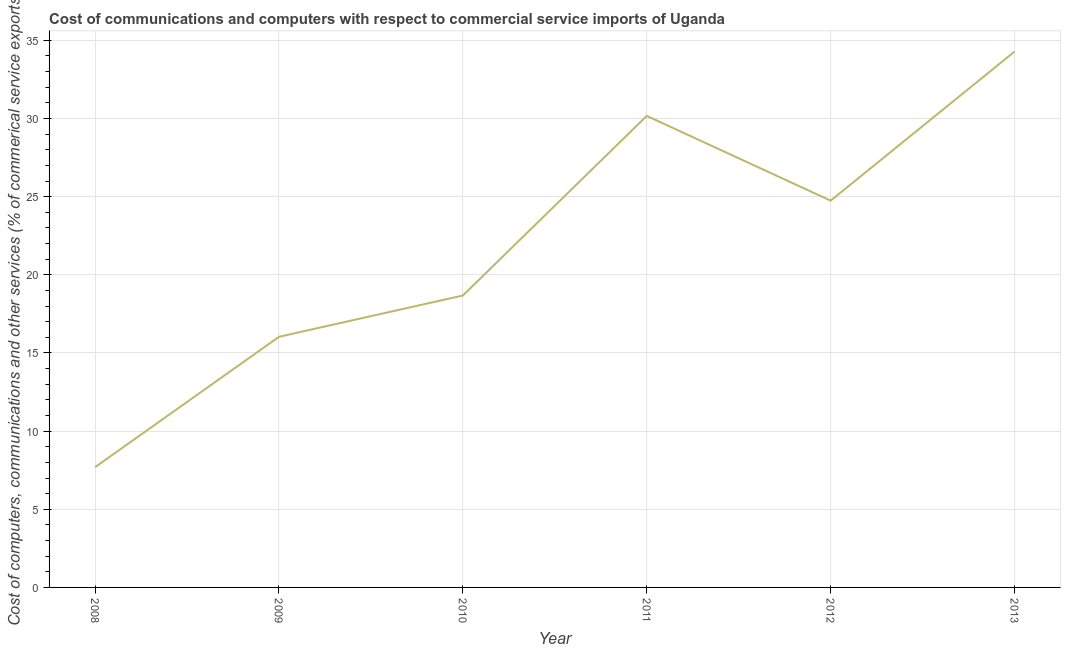What is the  computer and other services in 2010?
Keep it short and to the point. 18.68. Across all years, what is the maximum  computer and other services?
Your answer should be very brief. 34.28. Across all years, what is the minimum  computer and other services?
Offer a very short reply. 7.7. In which year was the  computer and other services maximum?
Your answer should be compact. 2013. What is the sum of the  computer and other services?
Offer a terse response. 131.6. What is the difference between the cost of communications in 2012 and 2013?
Give a very brief answer. -9.53. What is the average  computer and other services per year?
Give a very brief answer. 21.93. What is the median  computer and other services?
Your answer should be compact. 21.71. What is the ratio of the cost of communications in 2008 to that in 2009?
Keep it short and to the point. 0.48. What is the difference between the highest and the second highest  computer and other services?
Provide a short and direct response. 4.11. What is the difference between the highest and the lowest cost of communications?
Offer a terse response. 26.58. How many years are there in the graph?
Offer a very short reply. 6. What is the difference between two consecutive major ticks on the Y-axis?
Provide a short and direct response. 5. Does the graph contain grids?
Give a very brief answer. Yes. What is the title of the graph?
Your response must be concise. Cost of communications and computers with respect to commercial service imports of Uganda. What is the label or title of the Y-axis?
Provide a short and direct response. Cost of computers, communications and other services (% of commerical service exports). What is the Cost of computers, communications and other services (% of commerical service exports) of 2008?
Offer a terse response. 7.7. What is the Cost of computers, communications and other services (% of commerical service exports) in 2009?
Provide a succinct answer. 16.03. What is the Cost of computers, communications and other services (% of commerical service exports) in 2010?
Provide a succinct answer. 18.68. What is the Cost of computers, communications and other services (% of commerical service exports) of 2011?
Provide a short and direct response. 30.17. What is the Cost of computers, communications and other services (% of commerical service exports) of 2012?
Your answer should be very brief. 24.74. What is the Cost of computers, communications and other services (% of commerical service exports) of 2013?
Ensure brevity in your answer.  34.28. What is the difference between the Cost of computers, communications and other services (% of commerical service exports) in 2008 and 2009?
Make the answer very short. -8.34. What is the difference between the Cost of computers, communications and other services (% of commerical service exports) in 2008 and 2010?
Your response must be concise. -10.98. What is the difference between the Cost of computers, communications and other services (% of commerical service exports) in 2008 and 2011?
Your answer should be very brief. -22.47. What is the difference between the Cost of computers, communications and other services (% of commerical service exports) in 2008 and 2012?
Ensure brevity in your answer.  -17.05. What is the difference between the Cost of computers, communications and other services (% of commerical service exports) in 2008 and 2013?
Your answer should be compact. -26.58. What is the difference between the Cost of computers, communications and other services (% of commerical service exports) in 2009 and 2010?
Ensure brevity in your answer.  -2.64. What is the difference between the Cost of computers, communications and other services (% of commerical service exports) in 2009 and 2011?
Make the answer very short. -14.13. What is the difference between the Cost of computers, communications and other services (% of commerical service exports) in 2009 and 2012?
Your answer should be compact. -8.71. What is the difference between the Cost of computers, communications and other services (% of commerical service exports) in 2009 and 2013?
Provide a short and direct response. -18.25. What is the difference between the Cost of computers, communications and other services (% of commerical service exports) in 2010 and 2011?
Your answer should be very brief. -11.49. What is the difference between the Cost of computers, communications and other services (% of commerical service exports) in 2010 and 2012?
Ensure brevity in your answer.  -6.07. What is the difference between the Cost of computers, communications and other services (% of commerical service exports) in 2010 and 2013?
Keep it short and to the point. -15.6. What is the difference between the Cost of computers, communications and other services (% of commerical service exports) in 2011 and 2012?
Offer a very short reply. 5.42. What is the difference between the Cost of computers, communications and other services (% of commerical service exports) in 2011 and 2013?
Your response must be concise. -4.11. What is the difference between the Cost of computers, communications and other services (% of commerical service exports) in 2012 and 2013?
Offer a terse response. -9.53. What is the ratio of the Cost of computers, communications and other services (% of commerical service exports) in 2008 to that in 2009?
Provide a short and direct response. 0.48. What is the ratio of the Cost of computers, communications and other services (% of commerical service exports) in 2008 to that in 2010?
Your answer should be very brief. 0.41. What is the ratio of the Cost of computers, communications and other services (% of commerical service exports) in 2008 to that in 2011?
Provide a short and direct response. 0.26. What is the ratio of the Cost of computers, communications and other services (% of commerical service exports) in 2008 to that in 2012?
Your response must be concise. 0.31. What is the ratio of the Cost of computers, communications and other services (% of commerical service exports) in 2008 to that in 2013?
Provide a short and direct response. 0.23. What is the ratio of the Cost of computers, communications and other services (% of commerical service exports) in 2009 to that in 2010?
Provide a short and direct response. 0.86. What is the ratio of the Cost of computers, communications and other services (% of commerical service exports) in 2009 to that in 2011?
Keep it short and to the point. 0.53. What is the ratio of the Cost of computers, communications and other services (% of commerical service exports) in 2009 to that in 2012?
Offer a terse response. 0.65. What is the ratio of the Cost of computers, communications and other services (% of commerical service exports) in 2009 to that in 2013?
Give a very brief answer. 0.47. What is the ratio of the Cost of computers, communications and other services (% of commerical service exports) in 2010 to that in 2011?
Your answer should be compact. 0.62. What is the ratio of the Cost of computers, communications and other services (% of commerical service exports) in 2010 to that in 2012?
Provide a succinct answer. 0.76. What is the ratio of the Cost of computers, communications and other services (% of commerical service exports) in 2010 to that in 2013?
Offer a very short reply. 0.55. What is the ratio of the Cost of computers, communications and other services (% of commerical service exports) in 2011 to that in 2012?
Give a very brief answer. 1.22. What is the ratio of the Cost of computers, communications and other services (% of commerical service exports) in 2012 to that in 2013?
Offer a terse response. 0.72. 